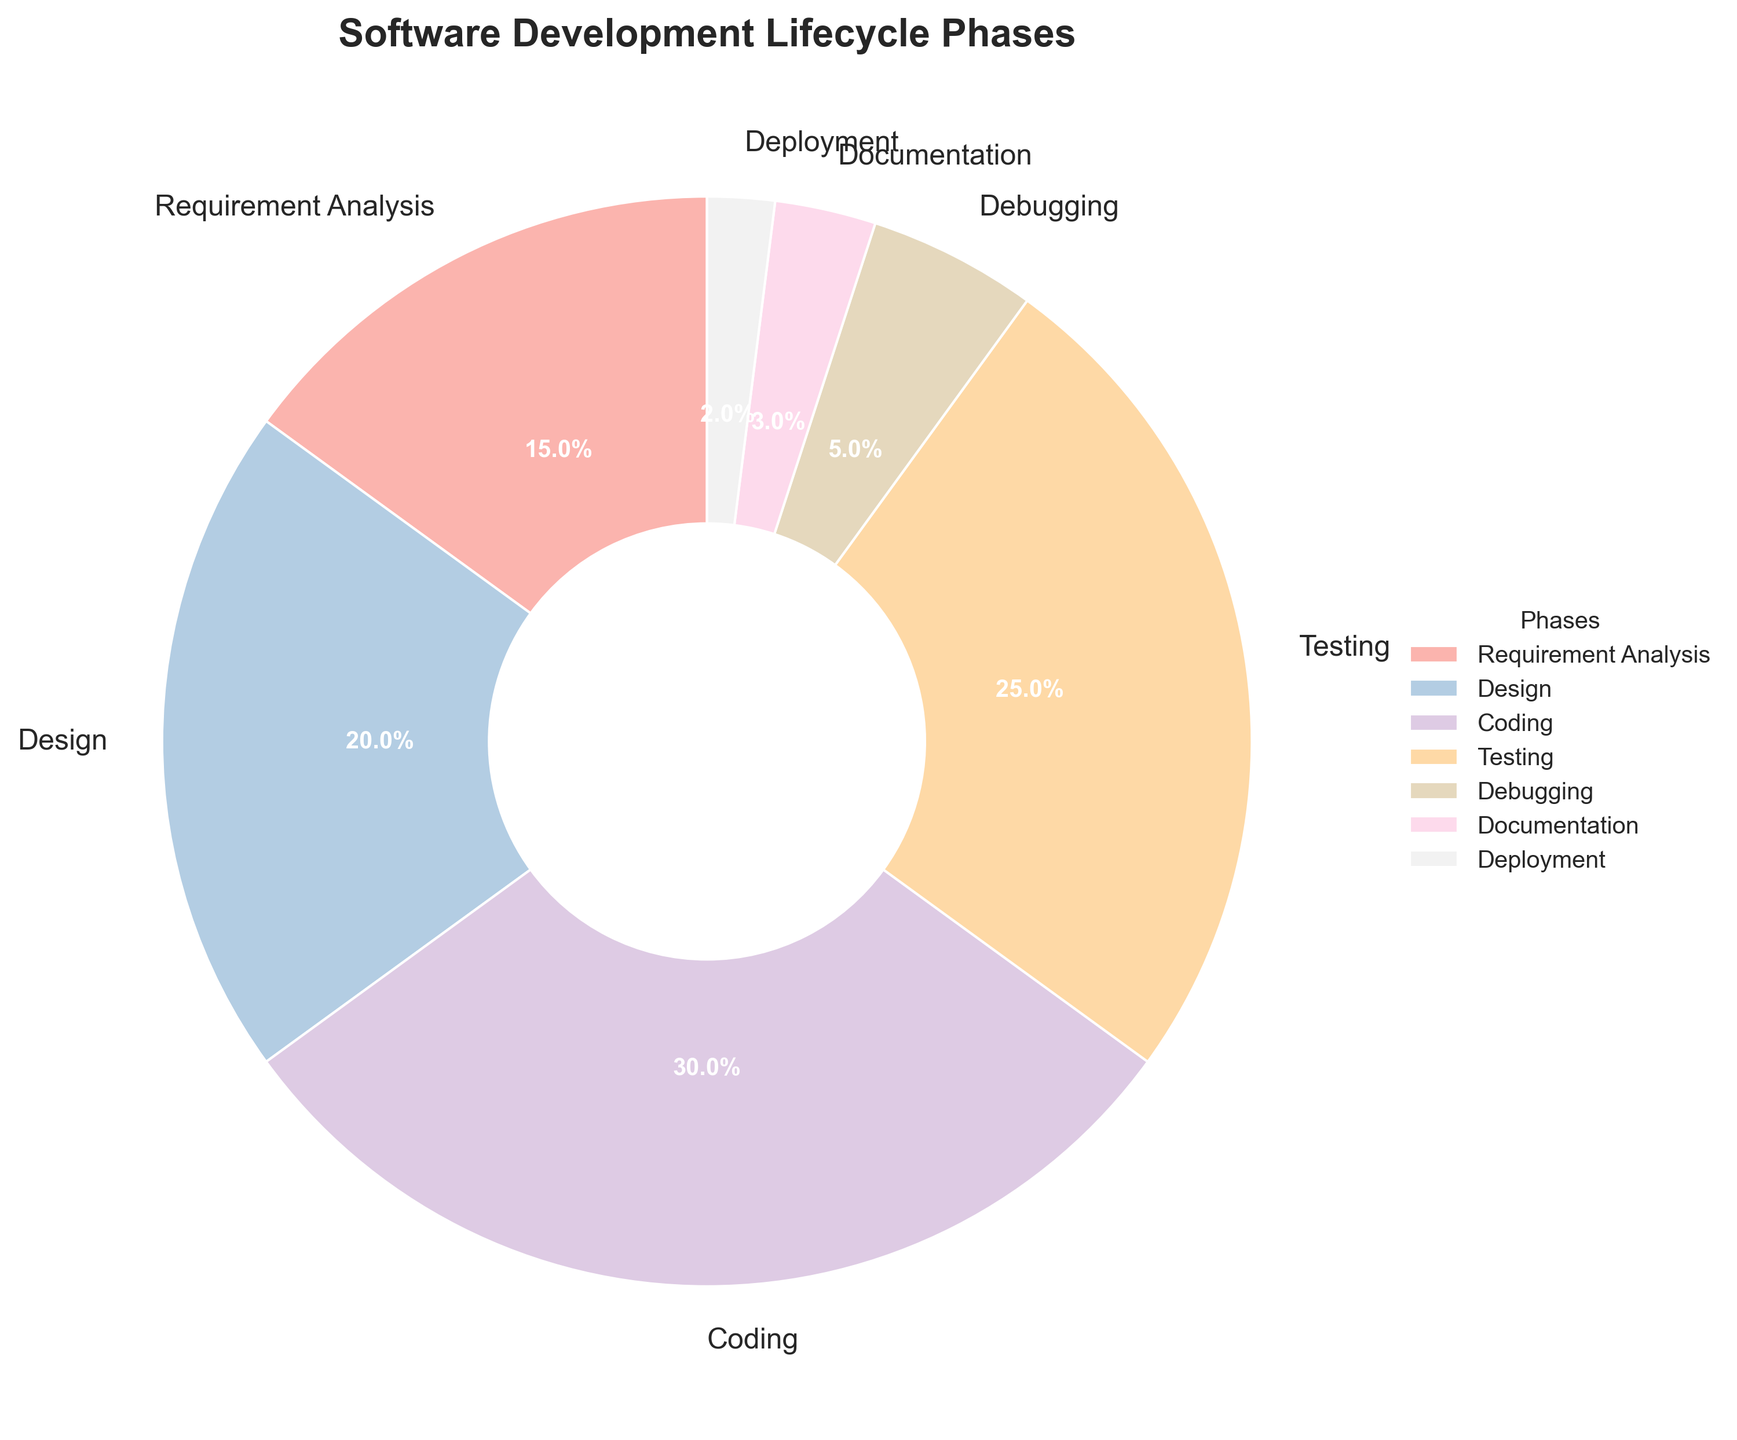What percentage of time is spent on Testing? The pie chart provides the percentage allocation of time spent on different phases. Testing constitutes 25% of the total time spent on the software development lifecycle.
Answer: 25% Which phase takes the least amount of time? By examining the pie chart, Deployment has the smallest segment, highlighting that it takes the least amount of time with just 2%.
Answer: Deployment How much more time is spent on Coding compared to Debugging? Coding is 30% while Debugging is 5%. Subtracting the two percentages (30% - 5%), we find that 25% more time is spent on Coding compared to Debugging.
Answer: 25% What is the combined percentage of time spent on Testing and Design? Testing accounts for 25% and Design for 20%. Adding these together, the combined percentage is 25% + 20% = 45%.
Answer: 45% If we group together Requirement Analysis, Testing, and Debugging, what percentage of time is spent collectively? Requirement Analysis is 15%, Testing is 25%, and Debugging is 5%. Adding these, we get 15% + 25% + 5% = 45%.
Answer: 45% Which phase has the highest allocation of time, and what is the percentage? Examining the pie chart, Coding has the largest segment, indicating it has the highest allocation of time at 30%.
Answer: Coding, 30% How does the time spent on Documentation compare to Deployment? Documentation takes 3% of the time, while Deployment takes 2%. Therefore, Documentation has a slightly higher allocation (3% vs 2%).
Answer: Documentation spends more time Which phases account for more than 20% of the time allocation each? From the pie chart, only Coding (30%) and Testing (25%) each account for more than 20% of the time allocation.
Answer: Coding and Testing By how much does the time spent on Design exceed that of Documentation? Design has a 20% allocation, whereas Documentation has 3%. Subtracting these values (20% - 3%), it exceeds by 17%.
Answer: 17% What's the visual color representation for the phase with the smallest percentage? The Deployment phase, which is the smallest segment, is represented by a light pastel color (depending on the specific color palette chosen, usually a light shade).
Answer: Light pastel color for Deployment 